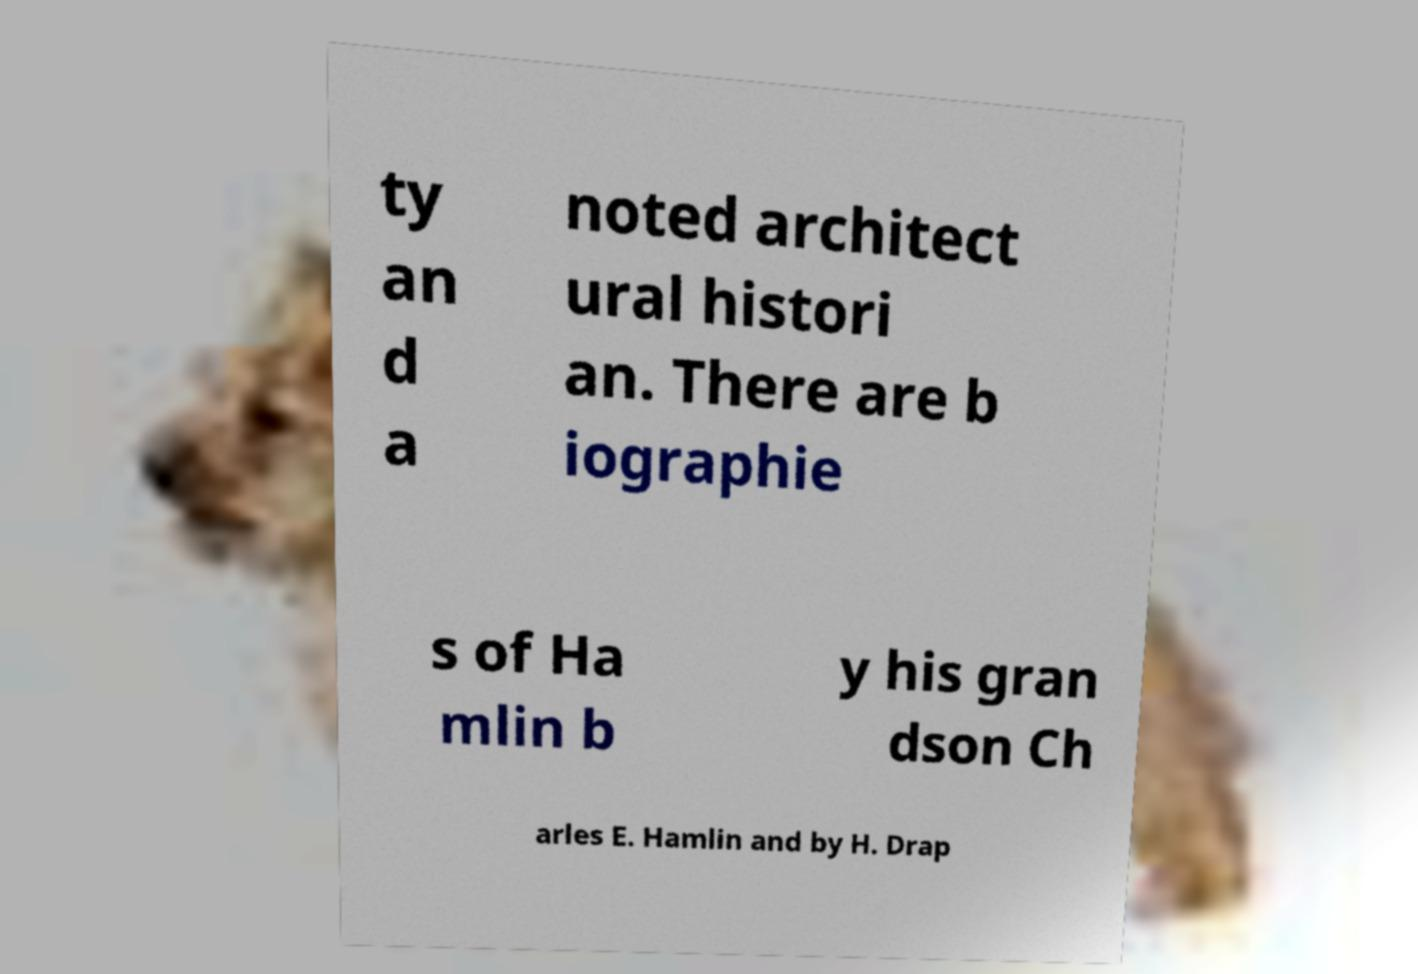Could you assist in decoding the text presented in this image and type it out clearly? ty an d a noted architect ural histori an. There are b iographie s of Ha mlin b y his gran dson Ch arles E. Hamlin and by H. Drap 